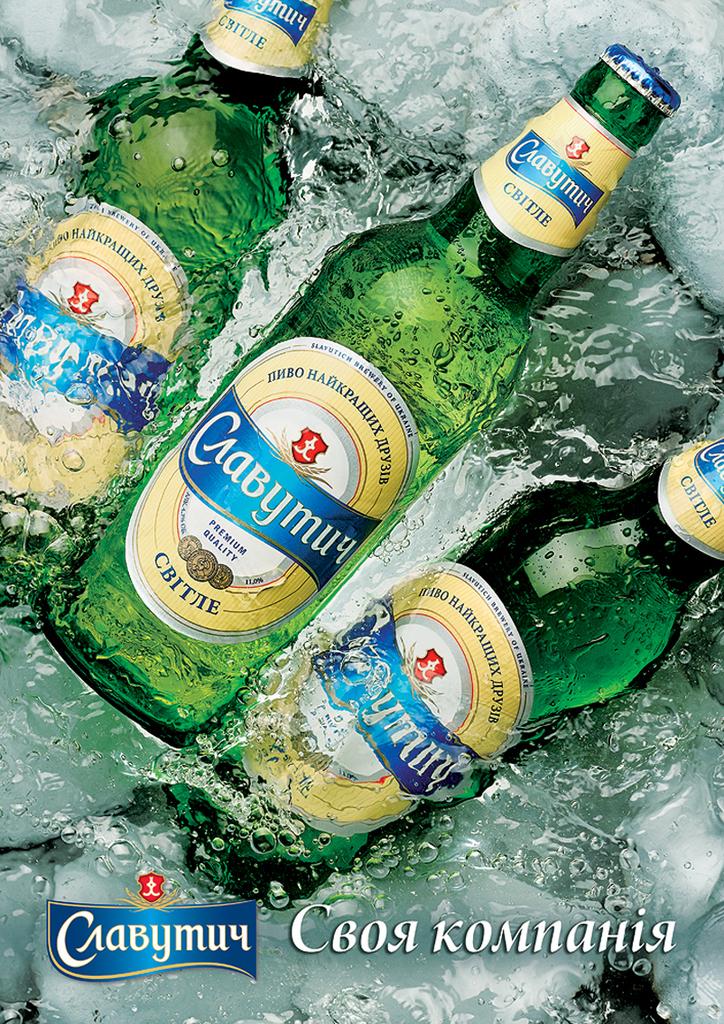What brand of beer is this?
Offer a very short reply. Crabymuy. 